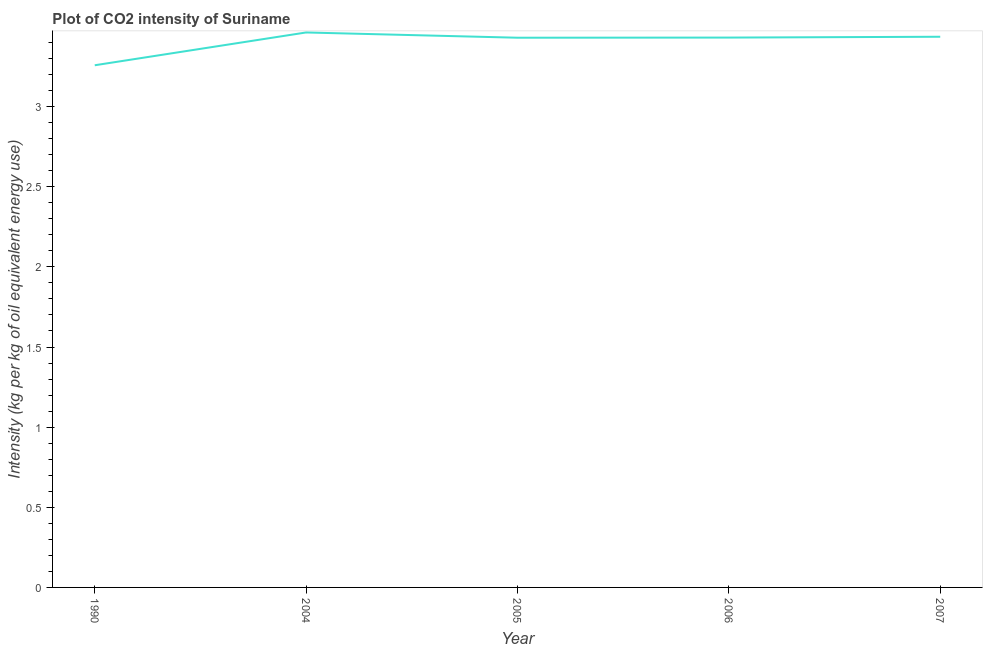What is the co2 intensity in 2006?
Offer a very short reply. 3.43. Across all years, what is the maximum co2 intensity?
Offer a terse response. 3.46. Across all years, what is the minimum co2 intensity?
Offer a very short reply. 3.26. In which year was the co2 intensity maximum?
Offer a very short reply. 2004. What is the sum of the co2 intensity?
Your answer should be compact. 17.02. What is the difference between the co2 intensity in 2005 and 2007?
Ensure brevity in your answer.  -0.01. What is the average co2 intensity per year?
Your answer should be compact. 3.4. What is the median co2 intensity?
Provide a succinct answer. 3.43. What is the ratio of the co2 intensity in 2005 to that in 2006?
Give a very brief answer. 1. Is the co2 intensity in 2004 less than that in 2006?
Offer a terse response. No. What is the difference between the highest and the second highest co2 intensity?
Offer a very short reply. 0.03. Is the sum of the co2 intensity in 1990 and 2007 greater than the maximum co2 intensity across all years?
Keep it short and to the point. Yes. What is the difference between the highest and the lowest co2 intensity?
Provide a short and direct response. 0.2. In how many years, is the co2 intensity greater than the average co2 intensity taken over all years?
Provide a succinct answer. 4. Does the co2 intensity monotonically increase over the years?
Provide a succinct answer. No. How many years are there in the graph?
Make the answer very short. 5. Does the graph contain any zero values?
Your answer should be very brief. No. Does the graph contain grids?
Your response must be concise. No. What is the title of the graph?
Your answer should be very brief. Plot of CO2 intensity of Suriname. What is the label or title of the X-axis?
Offer a very short reply. Year. What is the label or title of the Y-axis?
Your response must be concise. Intensity (kg per kg of oil equivalent energy use). What is the Intensity (kg per kg of oil equivalent energy use) of 1990?
Provide a short and direct response. 3.26. What is the Intensity (kg per kg of oil equivalent energy use) in 2004?
Provide a succinct answer. 3.46. What is the Intensity (kg per kg of oil equivalent energy use) of 2005?
Your response must be concise. 3.43. What is the Intensity (kg per kg of oil equivalent energy use) of 2006?
Offer a terse response. 3.43. What is the Intensity (kg per kg of oil equivalent energy use) in 2007?
Give a very brief answer. 3.44. What is the difference between the Intensity (kg per kg of oil equivalent energy use) in 1990 and 2004?
Offer a very short reply. -0.2. What is the difference between the Intensity (kg per kg of oil equivalent energy use) in 1990 and 2005?
Give a very brief answer. -0.17. What is the difference between the Intensity (kg per kg of oil equivalent energy use) in 1990 and 2006?
Offer a very short reply. -0.17. What is the difference between the Intensity (kg per kg of oil equivalent energy use) in 1990 and 2007?
Your answer should be compact. -0.18. What is the difference between the Intensity (kg per kg of oil equivalent energy use) in 2004 and 2005?
Your answer should be compact. 0.03. What is the difference between the Intensity (kg per kg of oil equivalent energy use) in 2004 and 2006?
Your response must be concise. 0.03. What is the difference between the Intensity (kg per kg of oil equivalent energy use) in 2004 and 2007?
Make the answer very short. 0.03. What is the difference between the Intensity (kg per kg of oil equivalent energy use) in 2005 and 2006?
Keep it short and to the point. -0. What is the difference between the Intensity (kg per kg of oil equivalent energy use) in 2005 and 2007?
Make the answer very short. -0.01. What is the difference between the Intensity (kg per kg of oil equivalent energy use) in 2006 and 2007?
Offer a terse response. -0.01. What is the ratio of the Intensity (kg per kg of oil equivalent energy use) in 1990 to that in 2004?
Your answer should be compact. 0.94. What is the ratio of the Intensity (kg per kg of oil equivalent energy use) in 1990 to that in 2006?
Offer a very short reply. 0.95. What is the ratio of the Intensity (kg per kg of oil equivalent energy use) in 1990 to that in 2007?
Provide a short and direct response. 0.95. What is the ratio of the Intensity (kg per kg of oil equivalent energy use) in 2004 to that in 2005?
Your answer should be compact. 1.01. What is the ratio of the Intensity (kg per kg of oil equivalent energy use) in 2004 to that in 2006?
Offer a terse response. 1.01. What is the ratio of the Intensity (kg per kg of oil equivalent energy use) in 2004 to that in 2007?
Your answer should be compact. 1.01. What is the ratio of the Intensity (kg per kg of oil equivalent energy use) in 2005 to that in 2006?
Ensure brevity in your answer.  1. 